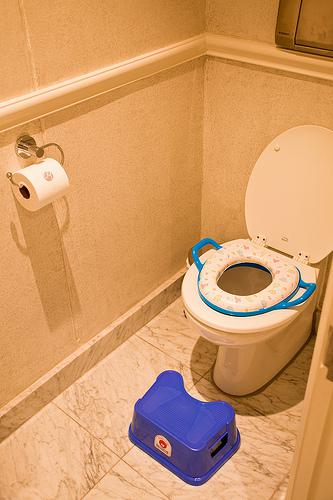Question: where is the potty seat?
Choices:
A. Floor.
B. On the toilet.
C. Bathroom.
D. Beside toilet.
Answer with the letter. Answer: B Question: what is on the toilet Paper?
Choices:
A. A sticker.
B. Plastic wrap.
C. Flower designs.
D. Stains.
Answer with the letter. Answer: A Question: what kind of tiles are on the floor?
Choices:
A. Marble.
B. Gray.
C. White.
D. Brown.
Answer with the letter. Answer: A 